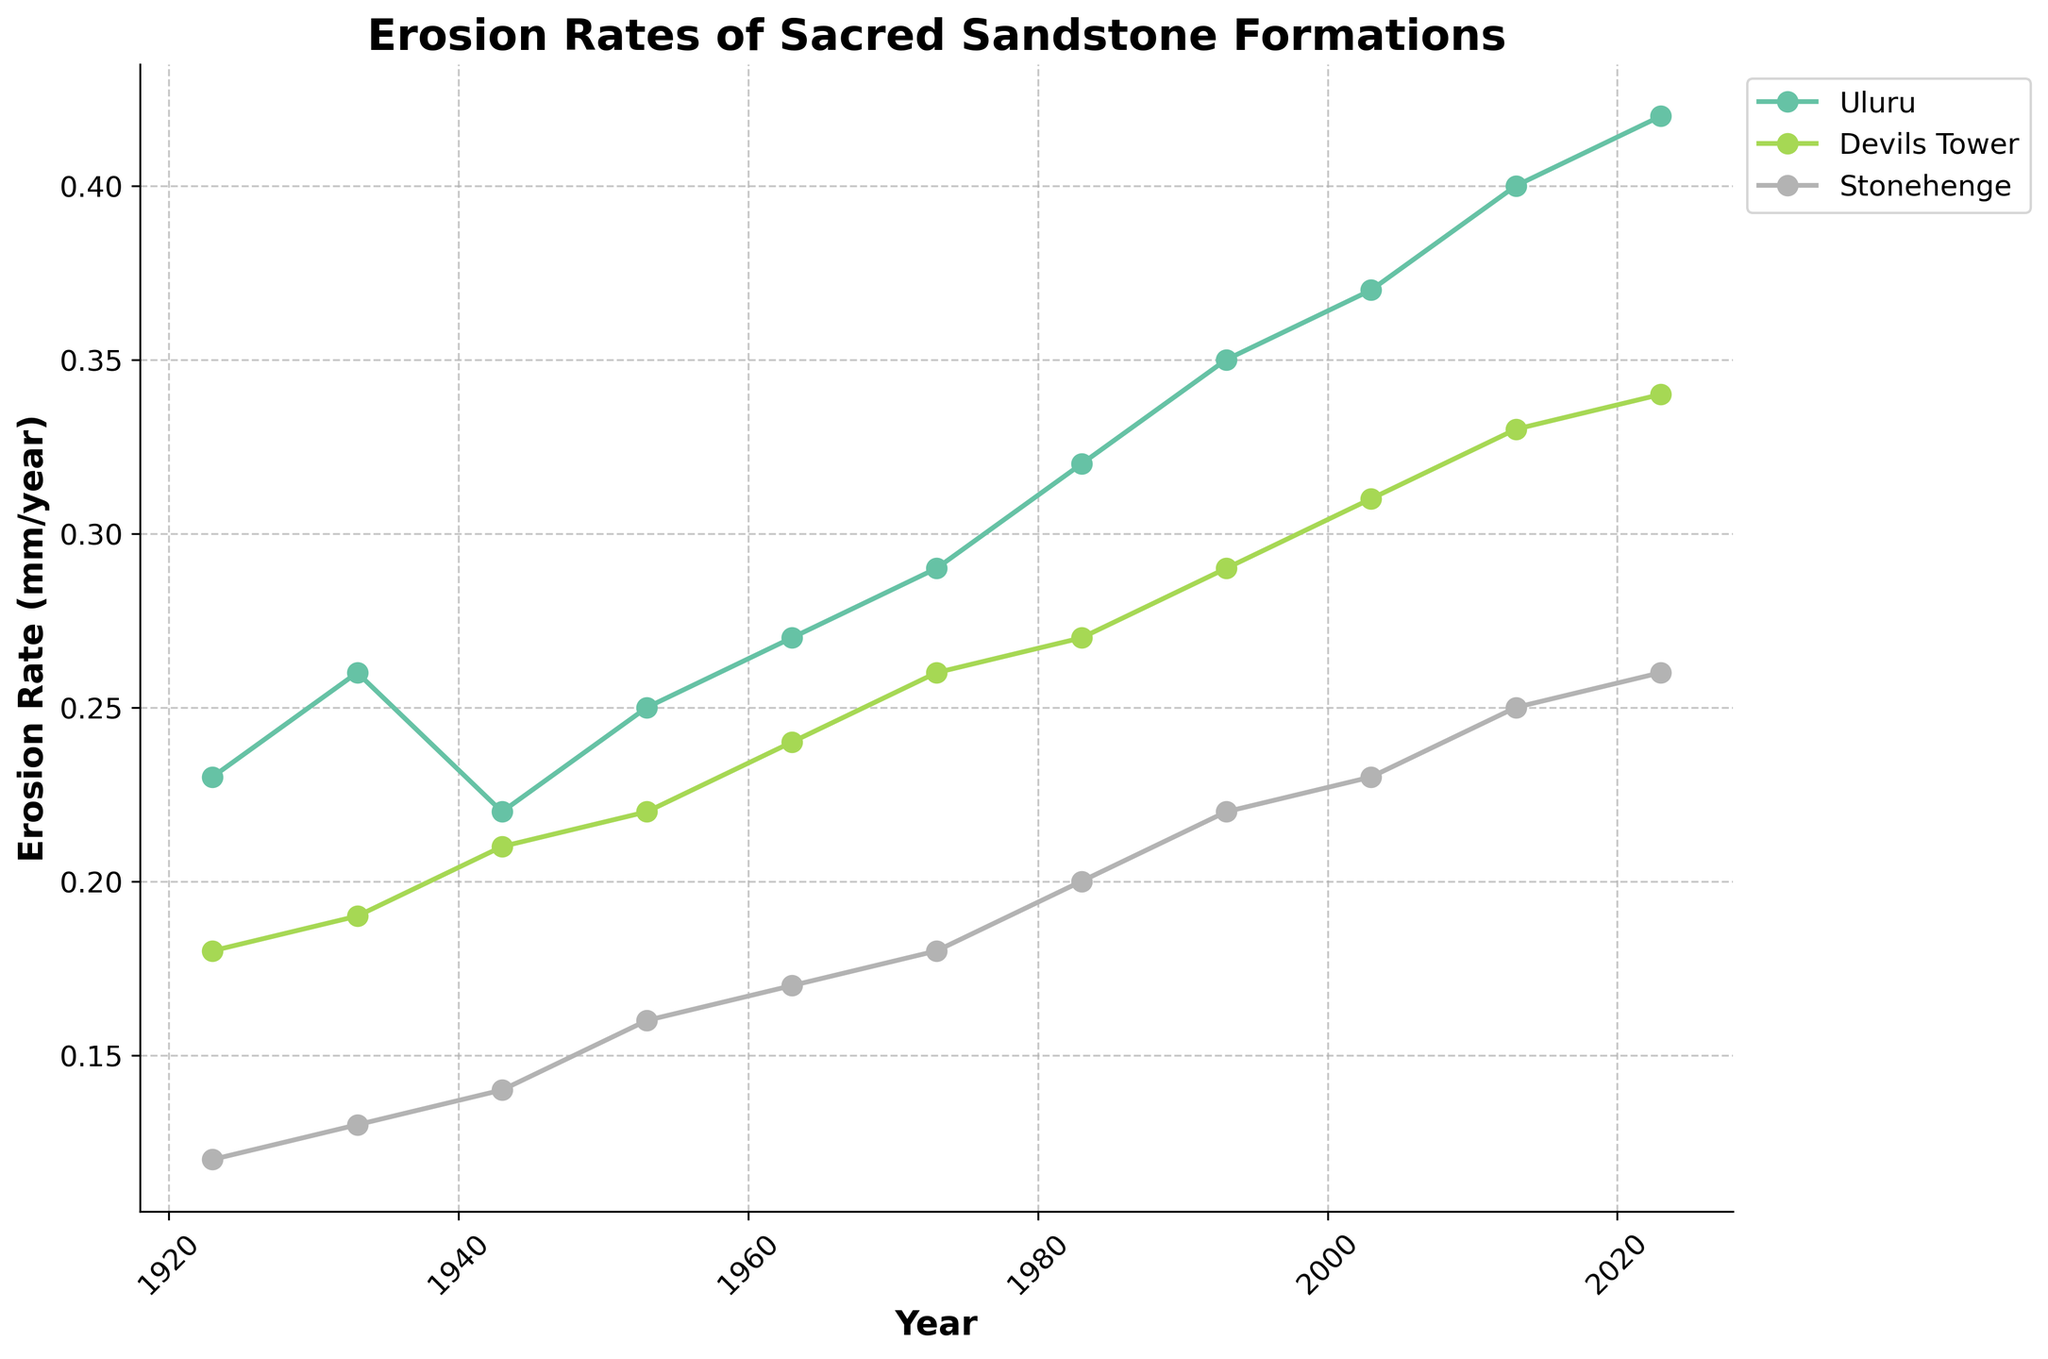What is the title of the plot? The title of the plot is usually placed at the top and summarises what is being represented. In this case, the title reads 'Erosion Rates of Sacred Sandstone Formations'.
Answer: Erosion Rates of Sacred Sandstone Formations Which location shows the highest erosion rate in 2023? To find this, look at the 2023 data points for each location. Uluru has an erosion rate of 0.42 mm/year, Devils Tower has 0.34 mm/year, and Stonehenge has 0.26 mm/year.
Answer: Uluru What is the erosion rate of Stonehenge in 1983? Locate the data point for Stonehenge in the year 1983, which shows an erosion rate of 0.20 mm/year.
Answer: 0.20 mm/year Which location had the fastest increase in erosion rates over the past century? To determine this, calculate the change in erosion rates over the century for each location. Uluru increased by (0.42 - 0.23) = 0.19 mm/year, Devils Tower increased by (0.34 - 0.18) = 0.16 mm/year, and Stonehenge increased by (0.26 - 0.12) = 0.14 mm/year.
Answer: Uluru In which decade did Devils Tower's erosion rate surpass 0.20 mm/year? Look at the year-by-year data for Devils Tower to see where the erosion rate exceeds 0.20 mm/year for the first time. In 1943, the erosion rate is 0.21 mm/year.
Answer: 1940s Comparing the years 1923 and 2023, by how much has the erosion rate increased for Stonehenge? Subtract the erosion rate of Stonehenge in 1923 (0.12 mm/year) from its rate in 2023 (0.26 mm/year). The increase is (0.26 - 0.12) = 0.14 mm/year.
Answer: 0.14 mm/year Which location has the most stable erosion rate trend over the past century? Assess the overall trends for each location. Stonehenge shows a smaller, more stable increase compared to Uluru and Devils Tower, which have larger fluctuations.
Answer: Stonehenge What was the general trend of erosion rates at Uluru from 1923 to 2023? Observing the plot for Uluru, it shows a steady increase in erosion rate over the century.
Answer: Increasing At what year did Uluru's erosion rate hit 0.30 mm/year for the first time? Check when Uluru's erosion rate crosses the 0.30 mm/year mark. In 1983, the rate is 0.32 mm/year.
Answer: 1983 Which location had the lowest erosion rate in 1933? In 1933, the erosion rates are 0.26 mm/year for Uluru, 0.19 mm/year for Devils Tower, and 0.13 mm/year for Stonehenge. Stonehenge has the lowest rate.
Answer: Stonehenge 